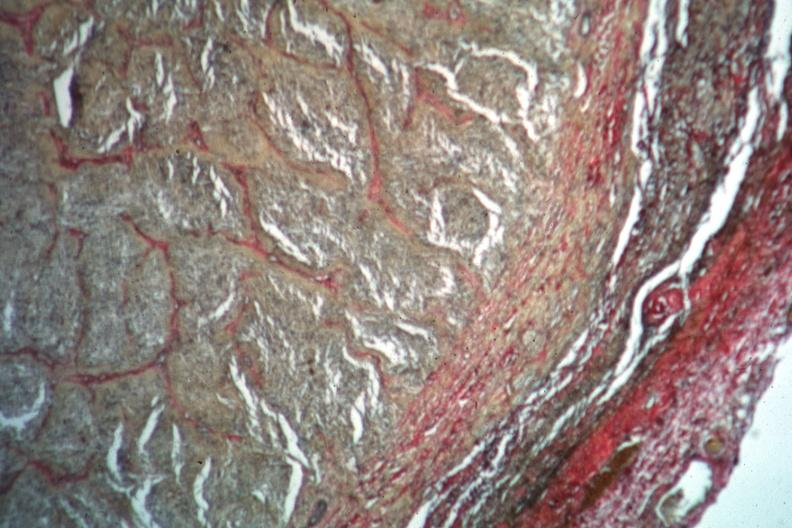does close-up tumor show van gieson?
Answer the question using a single word or phrase. No 